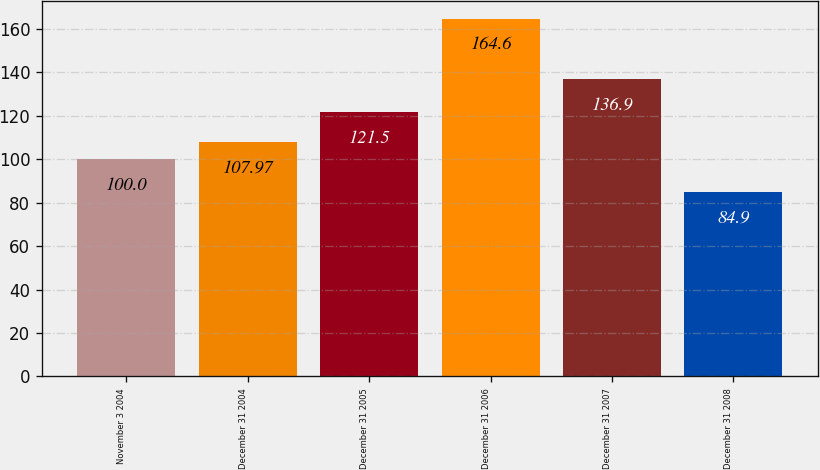Convert chart. <chart><loc_0><loc_0><loc_500><loc_500><bar_chart><fcel>November 3 2004<fcel>December 31 2004<fcel>December 31 2005<fcel>December 31 2006<fcel>December 31 2007<fcel>December 31 2008<nl><fcel>100<fcel>107.97<fcel>121.5<fcel>164.6<fcel>136.9<fcel>84.9<nl></chart> 